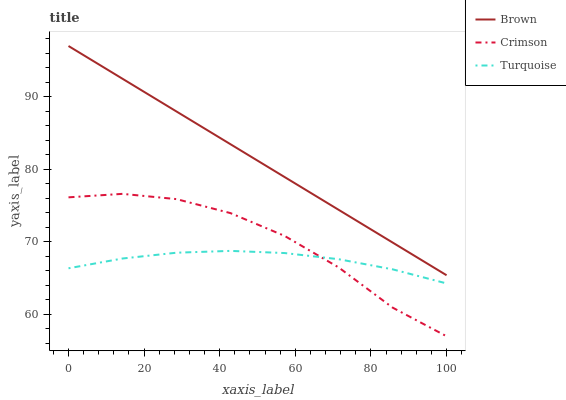Does Turquoise have the minimum area under the curve?
Answer yes or no. Yes. Does Brown have the maximum area under the curve?
Answer yes or no. Yes. Does Brown have the minimum area under the curve?
Answer yes or no. No. Does Turquoise have the maximum area under the curve?
Answer yes or no. No. Is Brown the smoothest?
Answer yes or no. Yes. Is Crimson the roughest?
Answer yes or no. Yes. Is Turquoise the smoothest?
Answer yes or no. No. Is Turquoise the roughest?
Answer yes or no. No. Does Crimson have the lowest value?
Answer yes or no. Yes. Does Turquoise have the lowest value?
Answer yes or no. No. Does Brown have the highest value?
Answer yes or no. Yes. Does Turquoise have the highest value?
Answer yes or no. No. Is Turquoise less than Brown?
Answer yes or no. Yes. Is Brown greater than Crimson?
Answer yes or no. Yes. Does Turquoise intersect Crimson?
Answer yes or no. Yes. Is Turquoise less than Crimson?
Answer yes or no. No. Is Turquoise greater than Crimson?
Answer yes or no. No. Does Turquoise intersect Brown?
Answer yes or no. No. 